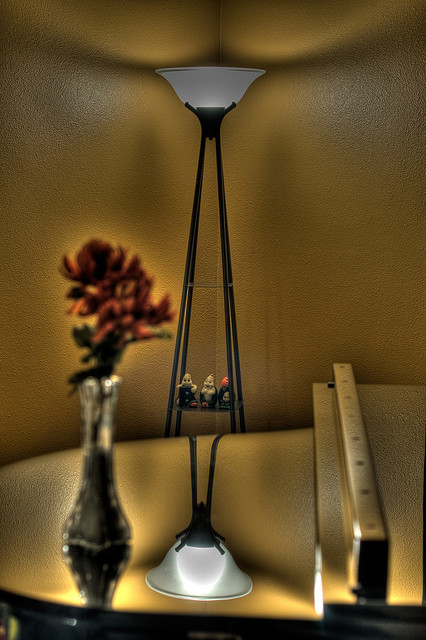<image>What musical instrument is in the picture? It is not certain which musical instrument is in the picture. Some possibilities are piano, harmonica, or violin. What musical instrument is in the picture? I am not sure what musical instrument is in the picture. It can be seen a piano, harmonica or a violin. 